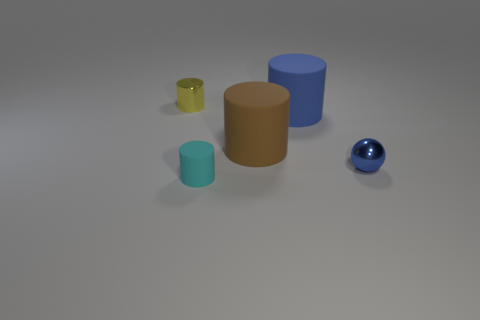Are there an equal number of blue rubber cylinders that are behind the yellow metallic object and cylinders?
Provide a succinct answer. No. The object that is both in front of the yellow metal cylinder and behind the brown matte object has what shape?
Provide a succinct answer. Cylinder. Do the blue rubber cylinder and the yellow thing have the same size?
Ensure brevity in your answer.  No. Are there any purple cubes that have the same material as the brown cylinder?
Make the answer very short. No. There is a cylinder that is the same color as the tiny sphere; what is its size?
Your answer should be compact. Large. How many tiny metallic things are on the left side of the ball and in front of the tiny yellow cylinder?
Keep it short and to the point. 0. There is a thing to the left of the cyan object; what material is it?
Your answer should be compact. Metal. How many big rubber cylinders are the same color as the small metal sphere?
Provide a succinct answer. 1. What is the size of the sphere that is made of the same material as the yellow cylinder?
Keep it short and to the point. Small. How many objects are tiny things or small gray metallic spheres?
Provide a succinct answer. 3. 